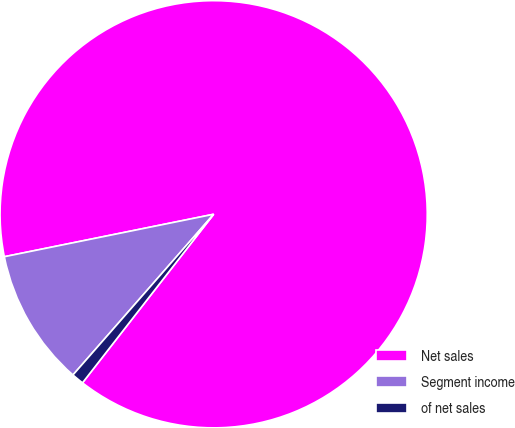Convert chart to OTSL. <chart><loc_0><loc_0><loc_500><loc_500><pie_chart><fcel>Net sales<fcel>Segment income<fcel>of net sales<nl><fcel>88.71%<fcel>10.37%<fcel>0.92%<nl></chart> 